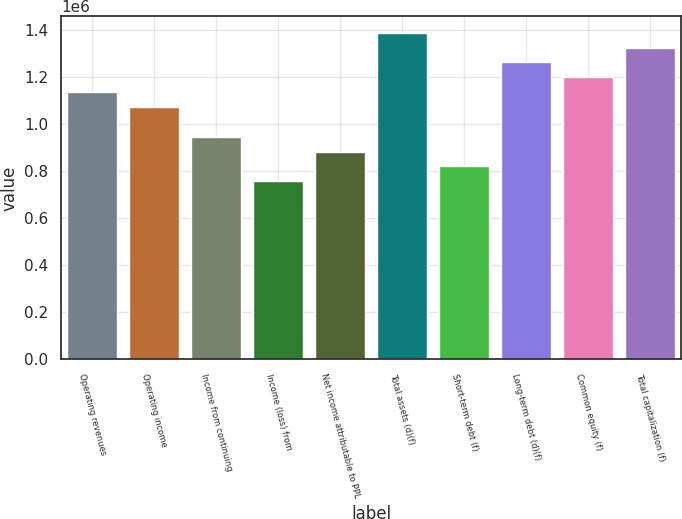Convert chart to OTSL. <chart><loc_0><loc_0><loc_500><loc_500><bar_chart><fcel>Operating revenues<fcel>Operating income<fcel>Income from continuing<fcel>Income (loss) from<fcel>Net income attributable to PPL<fcel>Total assets (d)(f)<fcel>Short-term debt (f)<fcel>Long-term debt (d)(f)<fcel>Common equity (f)<fcel>Total capitalization (f)<nl><fcel>1.13458e+06<fcel>1.07154e+06<fcel>945481<fcel>756385<fcel>882449<fcel>1.3867e+06<fcel>819417<fcel>1.26064e+06<fcel>1.19761e+06<fcel>1.32367e+06<nl></chart> 